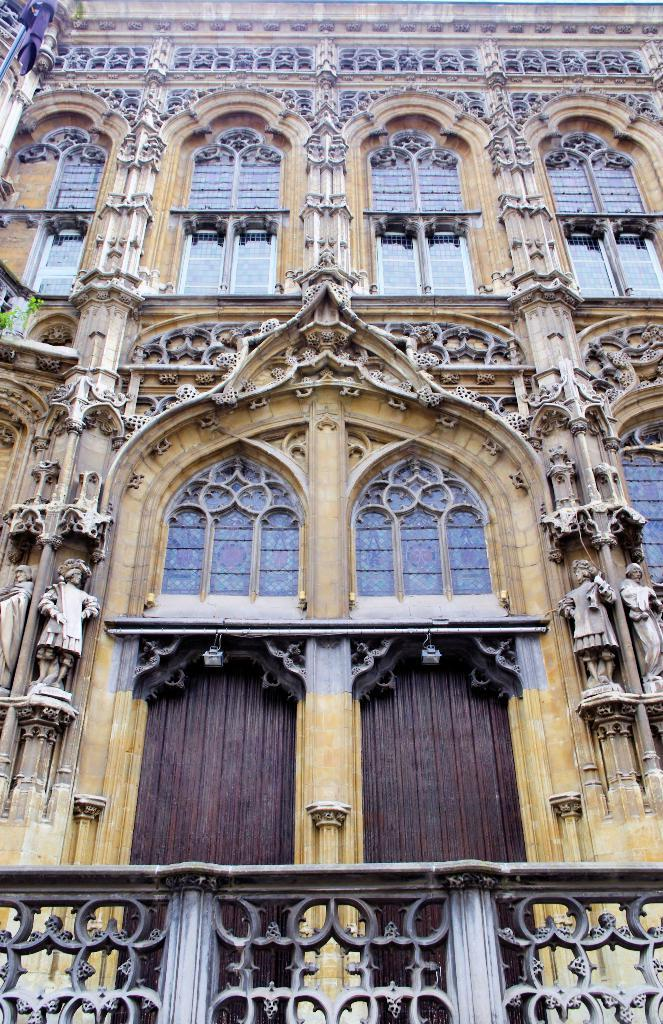What type of structure is present in the image? There is a building in the image. What is in front of the building? There is a fence in front of the building. What features can be seen on the building? The building has windows and doors. What additional objects are present in the image? There are sculptures and a flag in the image. What can be seen in the background of the image? The sky is visible in the image. How many expert water skiers are visible in the image? There are no water skiers present in the image, let alone expert water skiers. 